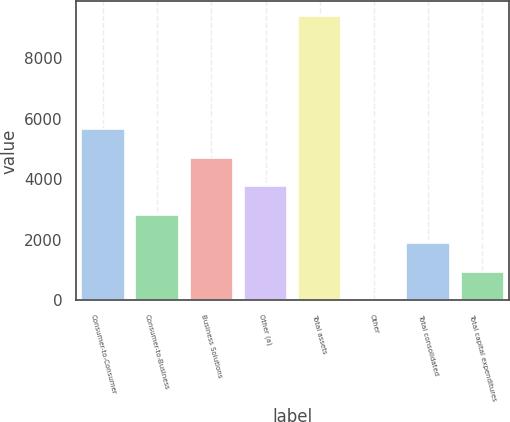Convert chart. <chart><loc_0><loc_0><loc_500><loc_500><bar_chart><fcel>Consumer-to-Consumer<fcel>Consumer-to-Business<fcel>Business Solutions<fcel>Other (a)<fcel>Total assets<fcel>Other<fcel>Total consolidated<fcel>Total capital expenditures<nl><fcel>5654.64<fcel>2830.92<fcel>4713.4<fcel>3772.16<fcel>9419.6<fcel>7.2<fcel>1889.68<fcel>948.44<nl></chart> 